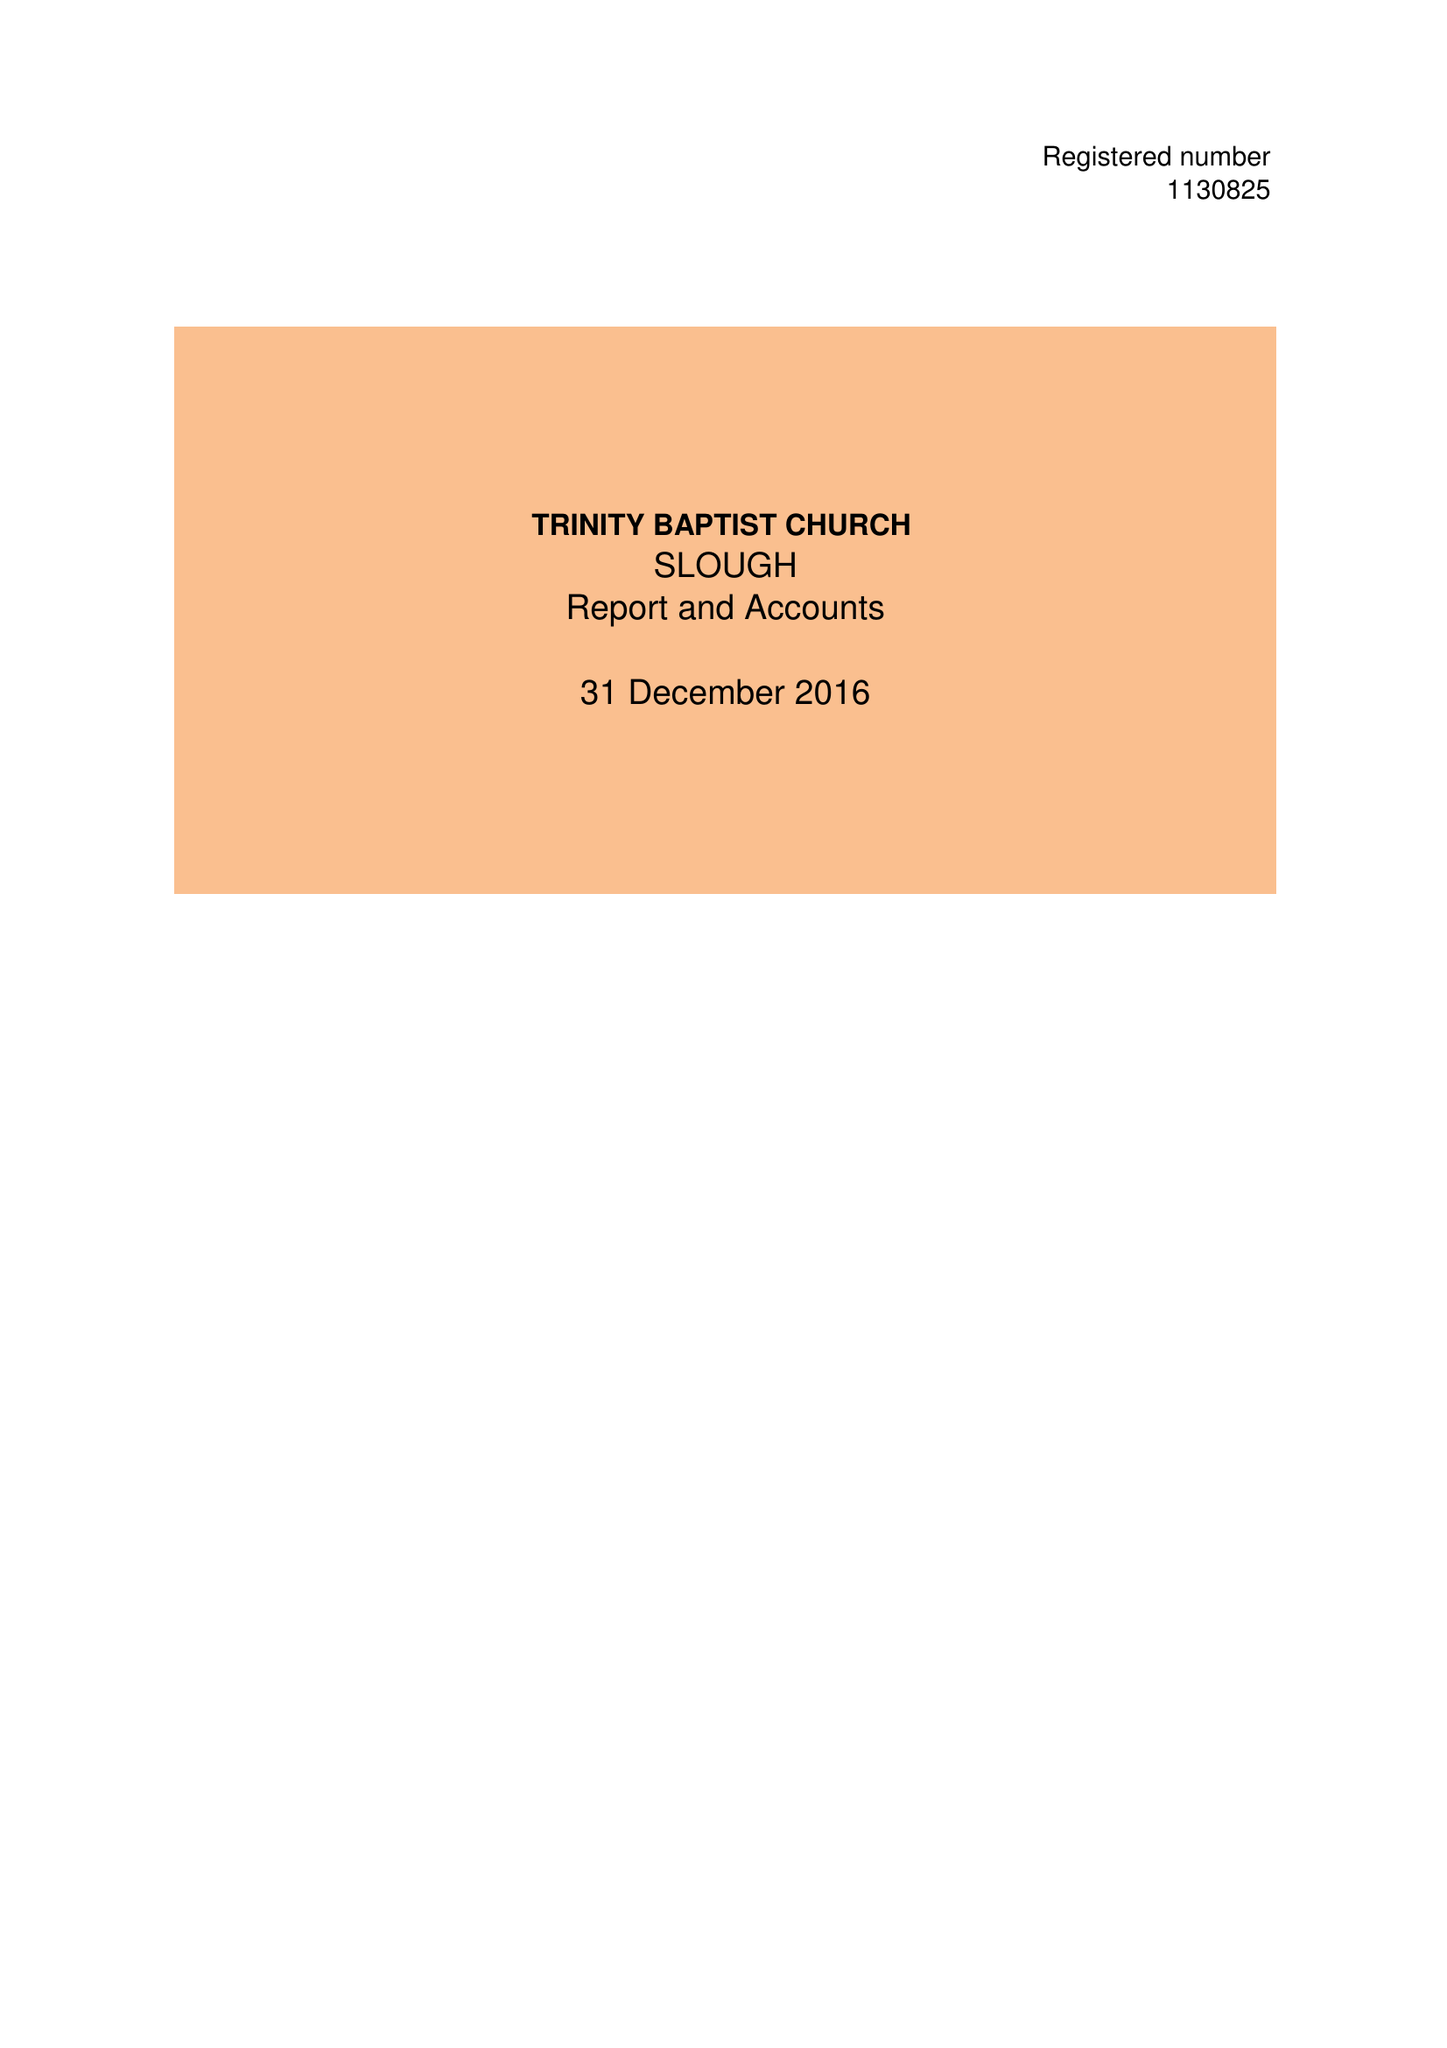What is the value for the income_annually_in_british_pounds?
Answer the question using a single word or phrase. 45785.00 